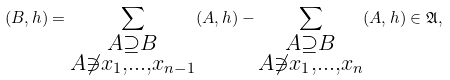Convert formula to latex. <formula><loc_0><loc_0><loc_500><loc_500>( B , h ) = \sum _ { \substack { A \supseteq B \\ A \not \ni x _ { 1 } , \dots , x _ { n - 1 } } } ( A , h ) - \sum _ { \substack { A \supseteq B \\ A \not \ni x _ { 1 } , \dots , x _ { n } } } ( A , h ) \in \mathfrak { A } ,</formula> 